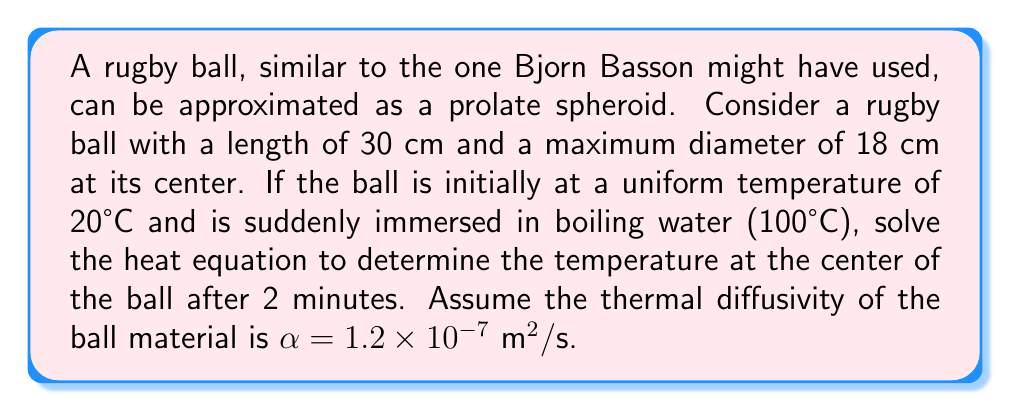Could you help me with this problem? To solve this problem, we'll use the heat equation for a prolate spheroid in spheroidal coordinates:

$$\frac{\partial T}{\partial t} = \alpha \left[\frac{1}{a^2(u^2+v^2)}\left(\frac{\partial}{\partial u}((u^2+1)\frac{\partial T}{\partial u}) + \frac{\partial}{\partial v}((1-v^2)\frac{\partial T}{\partial v})\right)\right]$$

Where $a$ is the semi-major axis, $u$ is the radial coordinate, and $v$ is the angular coordinate.

Step 1: Calculate the semi-major axis $a$ and eccentricity $e$:
$a = 15 \text{ cm} = 0.15 \text{ m}$
$b = 9 \text{ cm} = 0.09 \text{ m}$
$e = \sqrt{1-\frac{b^2}{a^2}} = \sqrt{1-\frac{0.09^2}{0.15^2}} \approx 0.8165$

Step 2: Use the separation of variables method to solve the heat equation:
$$T(u,v,t) = \sum_{n=0}^{\infty} \sum_{m=0}^{\infty} A_{nm} P_n^m(u) P_n^m(v) e^{-\lambda_{nm}^2 \alpha t}$$

Where $P_n^m$ are associated Legendre functions, and $\lambda_{nm}$ are eigenvalues.

Step 3: For the center of the ball, $u=0$ and $v=0$. The solution simplifies to:
$$T(0,0,t) = \sum_{n=0}^{\infty} A_{n0} P_n(0) e^{-\lambda_{n0}^2 \alpha t}$$

Step 4: The first term (n=0) dominates for long times, so we can approximate:
$$T(0,0,t) \approx A_{00} e^{-\lambda_{00}^2 \alpha t}$$

Step 5: $\lambda_{00}$ for a prolate spheroid is given by:
$$\lambda_{00} = \frac{\pi}{2a\ln(\frac{1+e}{1-e})}$$

Step 6: Calculate $\lambda_{00}$:
$$\lambda_{00} = \frac{\pi}{2(0.15)\ln(\frac{1+0.8165}{1-0.8165})} \approx 6.9052 \text{ m}^{-1}$$

Step 7: Use the initial and boundary conditions to find $A_{00}$:
$A_{00} = T_f - (T_f - T_i) = 100 - (100 - 20) = 20$

Step 8: Calculate the temperature at the center after 2 minutes (120 seconds):
$$T(0,0,120) \approx 100 - 80e^{-(6.9052)^2 \cdot 1.2 \times 10^{-7} \cdot 120} \approx 78.3°C$$
Answer: 78.3°C 